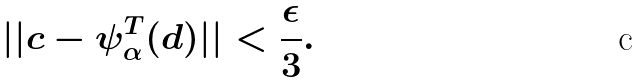Convert formula to latex. <formula><loc_0><loc_0><loc_500><loc_500>| | c - \psi _ { \alpha } ^ { T } ( d ) | | < \frac { \epsilon } { 3 } .</formula> 